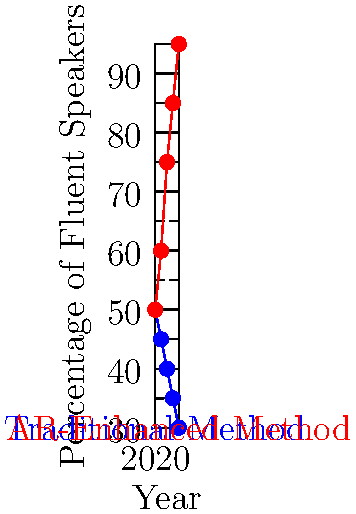Based on the graph showing the percentage of fluent speakers in an indigenous language over time, what is the projected difference in fluency rates between traditional and AR-enhanced language preservation methods by 2024? To find the difference in fluency rates between traditional and AR-enhanced methods in 2024:

1. Identify the fluency rate for traditional method in 2024:
   Traditional method in 2024: 30%

2. Identify the fluency rate for AR-enhanced method in 2024:
   AR-enhanced method in 2024: 95%

3. Calculate the difference:
   $95\% - 30\% = 65\%$

The projected difference in fluency rates between AR-enhanced and traditional methods by 2024 is 65 percentage points.

This substantial difference suggests that AR-enhanced methods could significantly outperform traditional methods in preserving indigenous language fluency over time.
Answer: 65% 